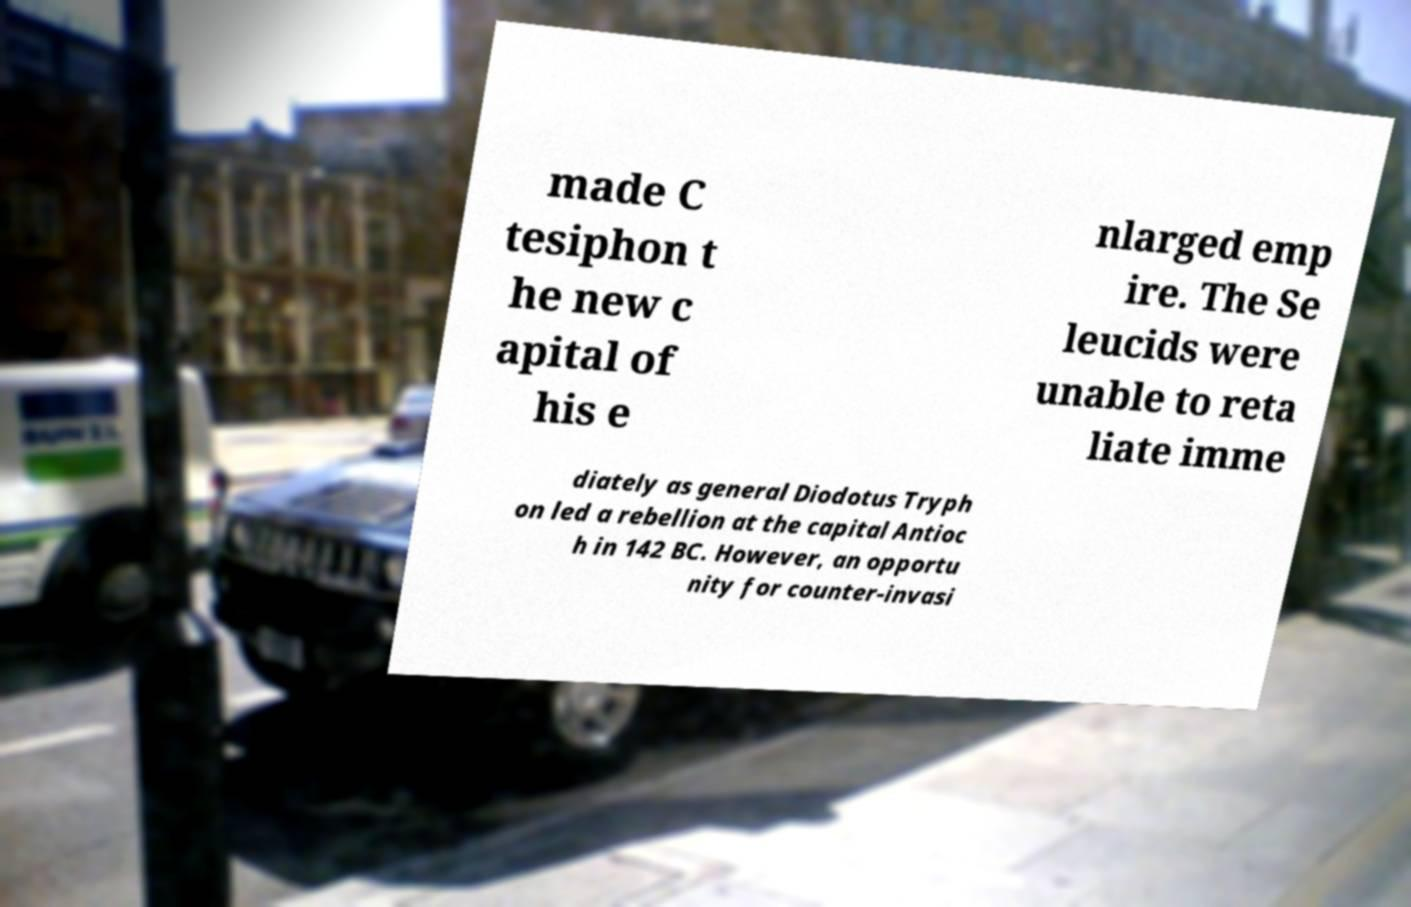Please identify and transcribe the text found in this image. made C tesiphon t he new c apital of his e nlarged emp ire. The Se leucids were unable to reta liate imme diately as general Diodotus Tryph on led a rebellion at the capital Antioc h in 142 BC. However, an opportu nity for counter-invasi 